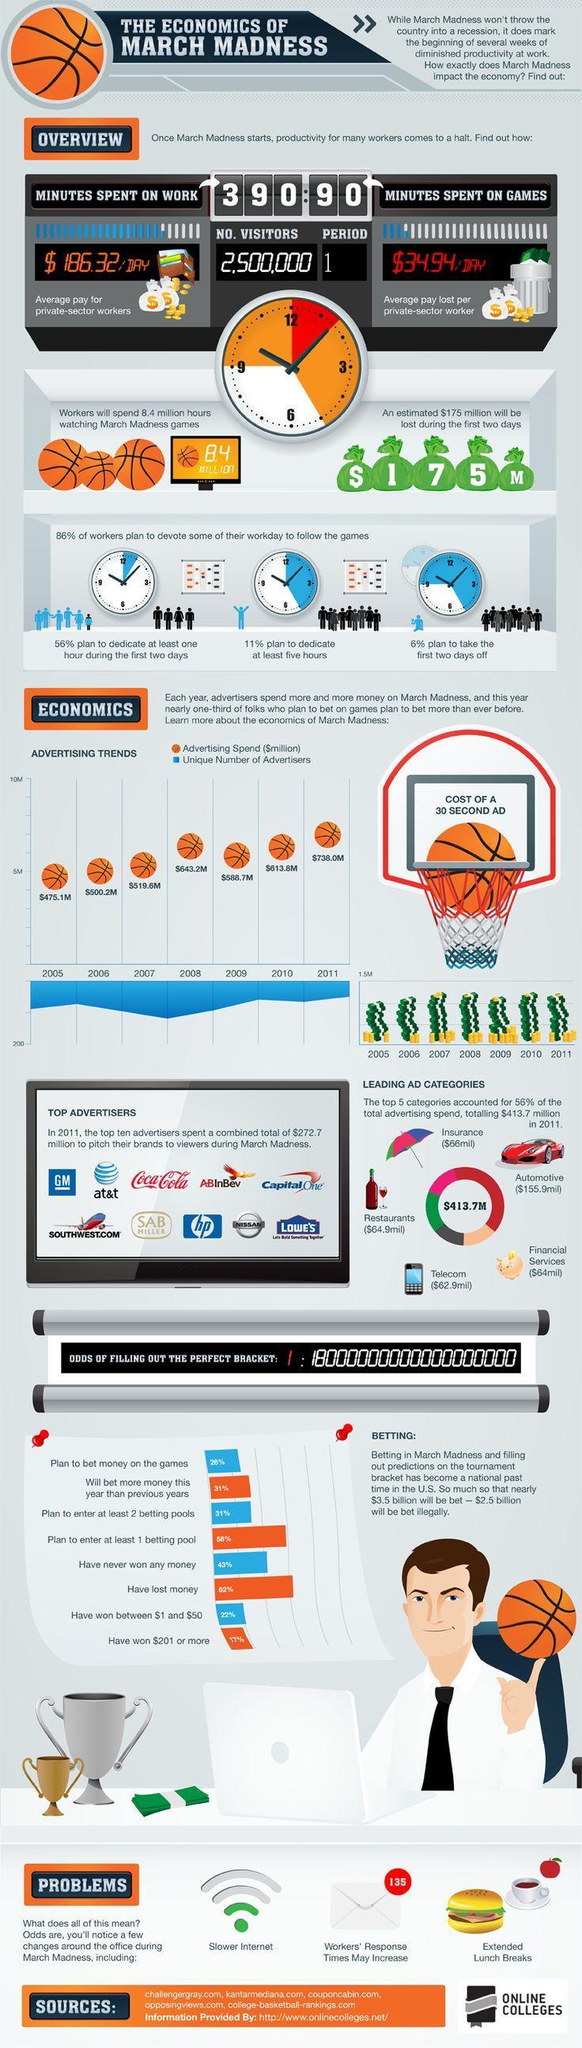what is the loss of revenue on the first 2 days of the game
Answer the question with a short phrase. $175 million how many hours are spent on games 1.5 Which year has the advertising spend been the second lowest 2006 Which brewing or beverage company were in the top ten advertisers Coca Coal, ABInBev, SAB Miller What is March Madness, foot ball or basket ball Basket Ball How many hours are spent on work 6.5 